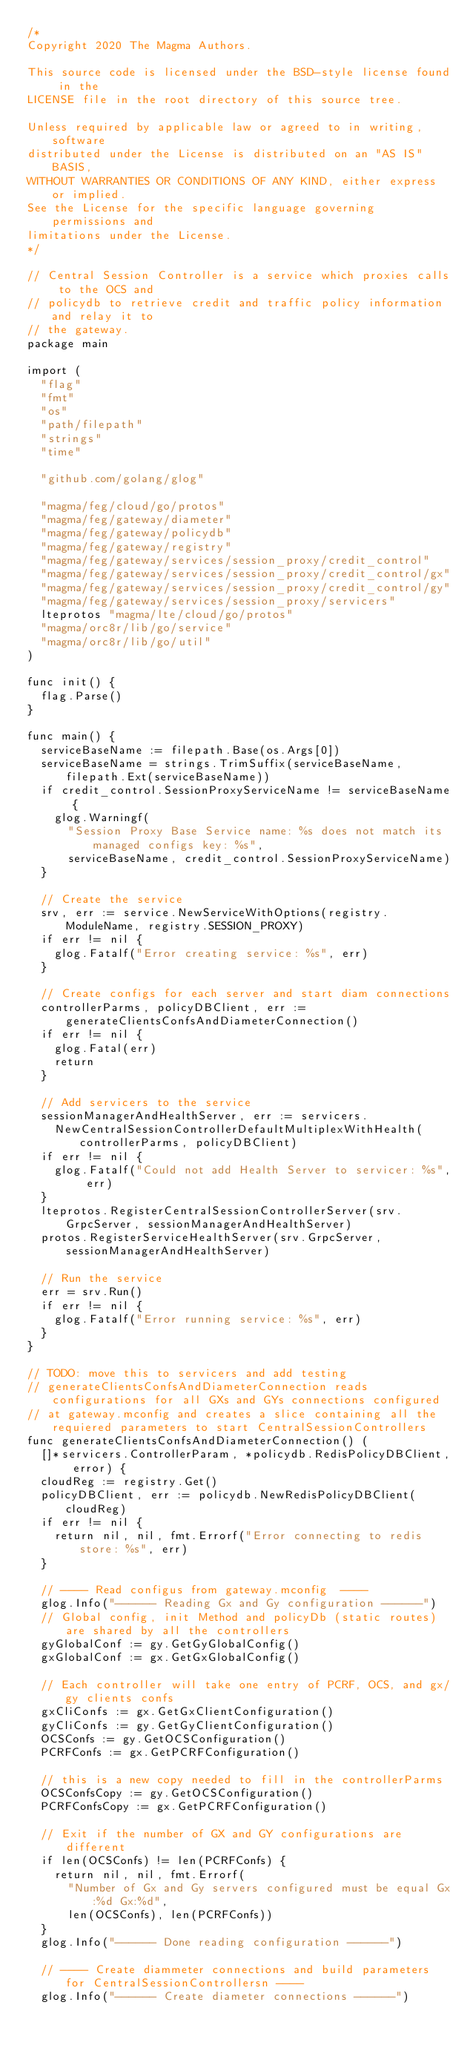Convert code to text. <code><loc_0><loc_0><loc_500><loc_500><_Go_>/*
Copyright 2020 The Magma Authors.

This source code is licensed under the BSD-style license found in the
LICENSE file in the root directory of this source tree.

Unless required by applicable law or agreed to in writing, software
distributed under the License is distributed on an "AS IS" BASIS,
WITHOUT WARRANTIES OR CONDITIONS OF ANY KIND, either express or implied.
See the License for the specific language governing permissions and
limitations under the License.
*/

// Central Session Controller is a service which proxies calls to the OCS and
// policydb to retrieve credit and traffic policy information and relay it to
// the gateway.
package main

import (
	"flag"
	"fmt"
	"os"
	"path/filepath"
	"strings"
	"time"

	"github.com/golang/glog"

	"magma/feg/cloud/go/protos"
	"magma/feg/gateway/diameter"
	"magma/feg/gateway/policydb"
	"magma/feg/gateway/registry"
	"magma/feg/gateway/services/session_proxy/credit_control"
	"magma/feg/gateway/services/session_proxy/credit_control/gx"
	"magma/feg/gateway/services/session_proxy/credit_control/gy"
	"magma/feg/gateway/services/session_proxy/servicers"
	lteprotos "magma/lte/cloud/go/protos"
	"magma/orc8r/lib/go/service"
	"magma/orc8r/lib/go/util"
)

func init() {
	flag.Parse()
}

func main() {
	serviceBaseName := filepath.Base(os.Args[0])
	serviceBaseName = strings.TrimSuffix(serviceBaseName, filepath.Ext(serviceBaseName))
	if credit_control.SessionProxyServiceName != serviceBaseName {
		glog.Warningf(
			"Session Proxy Base Service name: %s does not match its managed configs key: %s",
			serviceBaseName, credit_control.SessionProxyServiceName)
	}

	// Create the service
	srv, err := service.NewServiceWithOptions(registry.ModuleName, registry.SESSION_PROXY)
	if err != nil {
		glog.Fatalf("Error creating service: %s", err)
	}

	// Create configs for each server and start diam connections
	controllerParms, policyDBClient, err := generateClientsConfsAndDiameterConnection()
	if err != nil {
		glog.Fatal(err)
		return
	}

	// Add servicers to the service
	sessionManagerAndHealthServer, err := servicers.
		NewCentralSessionControllerDefaultMultiplexWithHealth(controllerParms, policyDBClient)
	if err != nil {
		glog.Fatalf("Could not add Health Server to servicer: %s", err)
	}
	lteprotos.RegisterCentralSessionControllerServer(srv.GrpcServer, sessionManagerAndHealthServer)
	protos.RegisterServiceHealthServer(srv.GrpcServer, sessionManagerAndHealthServer)

	// Run the service
	err = srv.Run()
	if err != nil {
		glog.Fatalf("Error running service: %s", err)
	}
}

// TODO: move this to servicers and add testing
// generateClientsConfsAndDiameterConnection reads configurations for all GXs and GYs connections configured
// at gateway.mconfig and creates a slice containing all the requiered parameters to start CentralSessionControllers
func generateClientsConfsAndDiameterConnection() (
	[]*servicers.ControllerParam, *policydb.RedisPolicyDBClient, error) {
	cloudReg := registry.Get()
	policyDBClient, err := policydb.NewRedisPolicyDBClient(cloudReg)
	if err != nil {
		return nil, nil, fmt.Errorf("Error connecting to redis store: %s", err)
	}

	// ---- Read configus from gateway.mconfig  ----
	glog.Info("------ Reading Gx and Gy configuration ------")
	// Global config, init Method and policyDb (static routes) are shared by all the controllers
	gyGlobalConf := gy.GetGyGlobalConfig()
	gxGlobalConf := gx.GetGxGlobalConfig()

	// Each controller will take one entry of PCRF, OCS, and gx/gy clients confs
	gxCliConfs := gx.GetGxClientConfiguration()
	gyCliConfs := gy.GetGyClientConfiguration()
	OCSConfs := gy.GetOCSConfiguration()
	PCRFConfs := gx.GetPCRFConfiguration()

	// this is a new copy needed to fill in the controllerParms
	OCSConfsCopy := gy.GetOCSConfiguration()
	PCRFConfsCopy := gx.GetPCRFConfiguration()

	// Exit if the number of GX and GY configurations are different
	if len(OCSConfs) != len(PCRFConfs) {
		return nil, nil, fmt.Errorf(
			"Number of Gx and Gy servers configured must be equal Gx:%d Gx:%d",
			len(OCSConfs), len(PCRFConfs))
	}
	glog.Info("------ Done reading configuration ------")

	// ---- Create diammeter connections and build parameters for CentralSessionControllersn ----
	glog.Info("------ Create diameter connections ------")</code> 